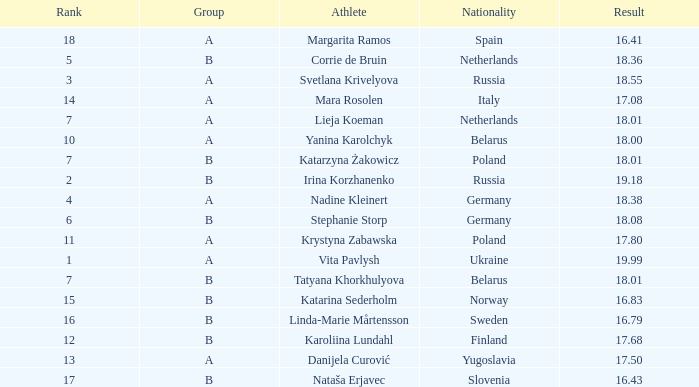What is the average rank for Group A athlete Yanina Karolchyk, and a result higher than 18? None. 